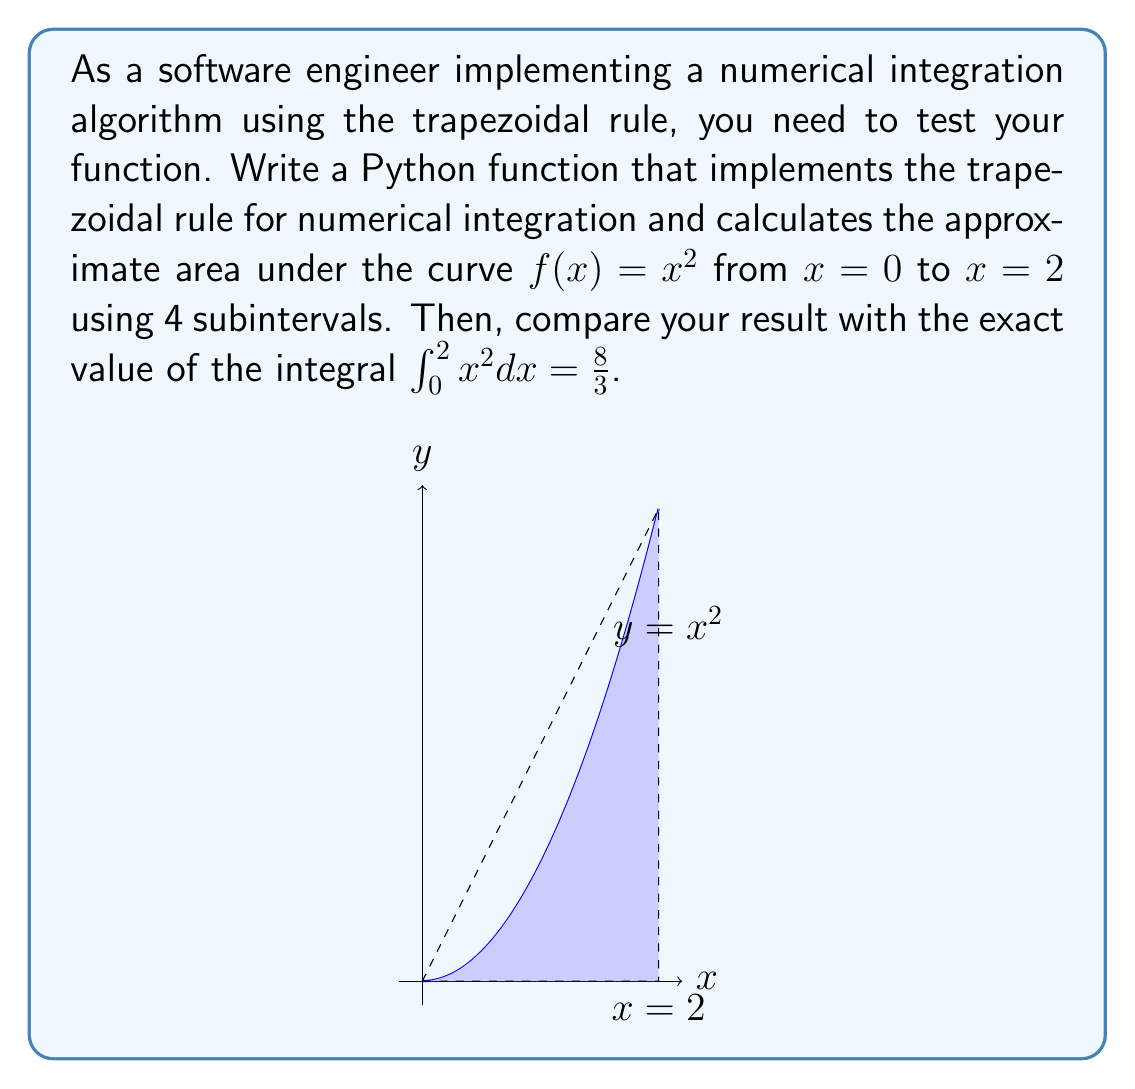Can you answer this question? Let's approach this step-by-step:

1) The trapezoidal rule approximates the integral as:

   $$\int_a^b f(x)dx \approx \frac{h}{2}[f(x_0) + 2f(x_1) + 2f(x_2) + ... + 2f(x_{n-1}) + f(x_n)]$$

   where $h = \frac{b-a}{n}$, and $n$ is the number of subintervals.

2) In our case, $a=0$, $b=2$, $n=4$, and $f(x) = x^2$

3) Calculate $h$:
   $h = \frac{2-0}{4} = 0.5$

4) Calculate the x-values:
   $x_0 = 0$
   $x_1 = 0.5$
   $x_2 = 1$
   $x_3 = 1.5$
   $x_4 = 2$

5) Calculate the corresponding f(x) values:
   $f(x_0) = 0^2 = 0$
   $f(x_1) = 0.5^2 = 0.25$
   $f(x_2) = 1^2 = 1$
   $f(x_3) = 1.5^2 = 2.25$
   $f(x_4) = 2^2 = 4$

6) Apply the trapezoidal rule:
   $$\text{Area} \approx \frac{0.5}{2}[0 + 2(0.25) + 2(1) + 2(2.25) + 4] = 0.25[0 + 0.5 + 2 + 4.5 + 4] = 0.25(11) = 2.75$$

7) The Python function to implement this could look like:

   ```python
   def trapezoidal_rule(f, a, b, n):
       h = (b - a) / n
       sum = 0.5 * (f(a) + f(b))
       for i in range(1, n):
           x = a + i * h
           sum += f(x)
       return h * sum

   def f(x):
       return x**2

   result = trapezoidal_rule(f, 0, 2, 4)
   print(f"Approximate area: {result}")
   print(f"Exact area: {8/3}")
   print(f"Absolute error: {abs(result - 8/3)}")
   ```

8) The exact value of the integral is $\frac{8}{3} \approx 2.6667$

9) The absolute error is $|2.75 - 2.6667| \approx 0.0833$

This demonstrates that the trapezoidal rule provides a reasonably close approximation, with an error of about 3.12% in this case.
Answer: 2.75 